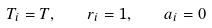<formula> <loc_0><loc_0><loc_500><loc_500>T _ { i } = T , \quad r _ { i } = 1 , \quad a _ { i } = 0</formula> 